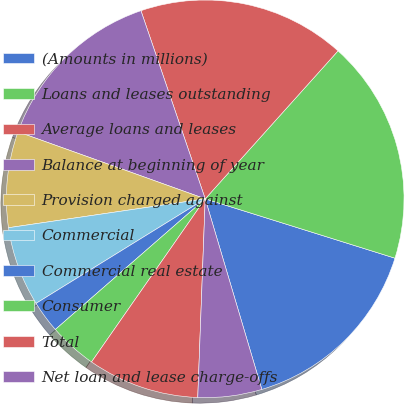Convert chart to OTSL. <chart><loc_0><loc_0><loc_500><loc_500><pie_chart><fcel>(Amounts in millions)<fcel>Loans and leases outstanding<fcel>Average loans and leases<fcel>Balance at beginning of year<fcel>Provision charged against<fcel>Commercial<fcel>Commercial real estate<fcel>Consumer<fcel>Total<fcel>Net loan and lease charge-offs<nl><fcel>15.58%<fcel>18.18%<fcel>16.88%<fcel>14.29%<fcel>7.79%<fcel>6.49%<fcel>2.6%<fcel>3.9%<fcel>9.09%<fcel>5.19%<nl></chart> 